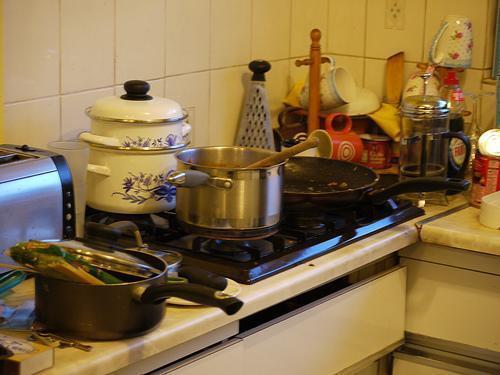How many pots are there?
Give a very brief answer. 1. 